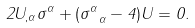Convert formula to latex. <formula><loc_0><loc_0><loc_500><loc_500>2 U _ { , \alpha } \sigma ^ { \alpha } + ( \sigma ^ { \alpha } _ { \ \alpha } - 4 ) U = 0 .</formula> 